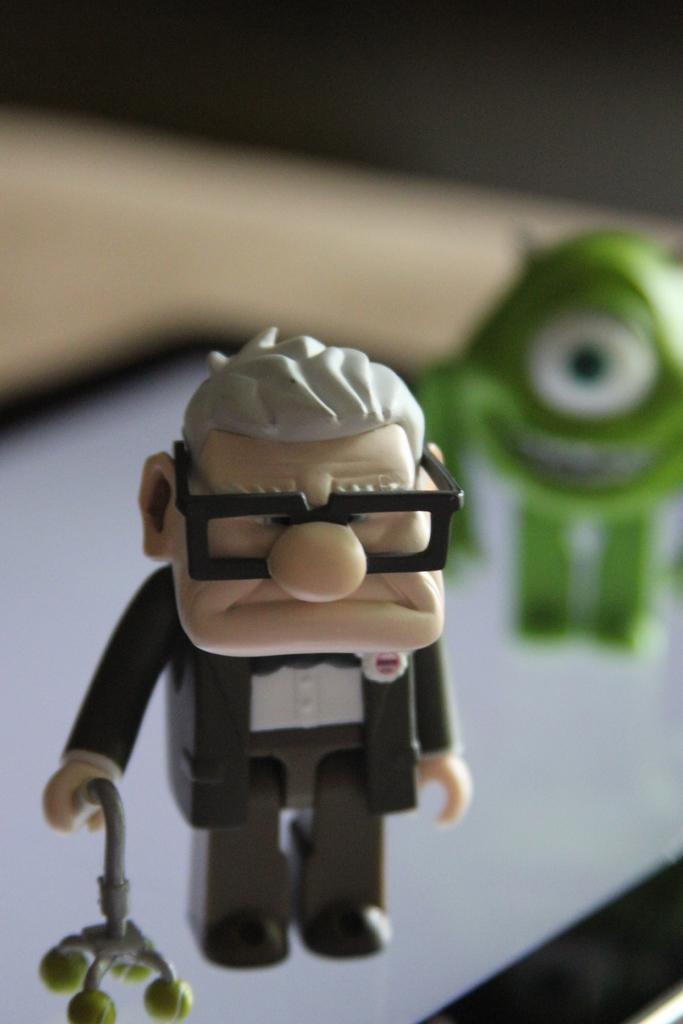What objects are present in the image? There are toys in the image. What colors can be seen on the toys? The toys have green, white, and black colors. Can you describe the toy holding a stick? Yes, there is a toy holding a stick in the image. What is the appearance of the background in the image? The background of the image is blurred. What type of planes can be seen flying in the image? There are no planes visible in the image; it features toys with green, white, and black colors. What kind of coach is present in the image? There is no coach present in the image; it only contains toys. 